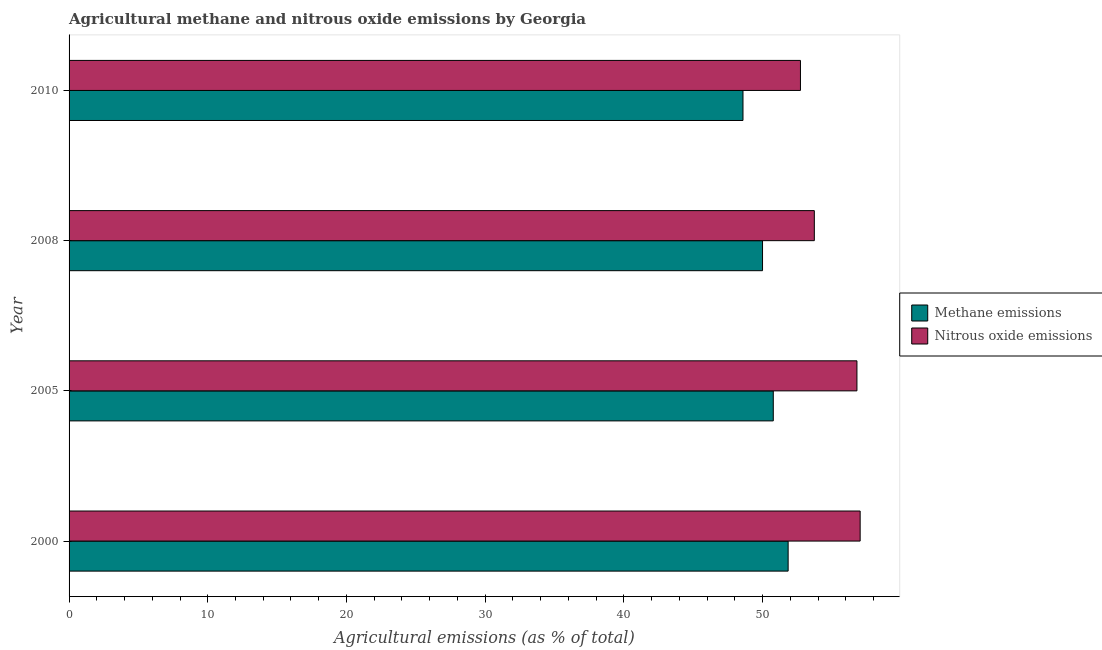How many different coloured bars are there?
Offer a terse response. 2. How many groups of bars are there?
Your answer should be very brief. 4. Are the number of bars per tick equal to the number of legend labels?
Your response must be concise. Yes. Are the number of bars on each tick of the Y-axis equal?
Make the answer very short. Yes. What is the amount of nitrous oxide emissions in 2005?
Keep it short and to the point. 56.81. Across all years, what is the maximum amount of nitrous oxide emissions?
Provide a short and direct response. 57.04. Across all years, what is the minimum amount of methane emissions?
Provide a short and direct response. 48.59. What is the total amount of nitrous oxide emissions in the graph?
Your answer should be compact. 220.31. What is the difference between the amount of nitrous oxide emissions in 2005 and that in 2008?
Keep it short and to the point. 3.07. What is the difference between the amount of methane emissions in 2005 and the amount of nitrous oxide emissions in 2010?
Provide a short and direct response. -1.96. What is the average amount of methane emissions per year?
Provide a succinct answer. 50.3. In the year 2010, what is the difference between the amount of methane emissions and amount of nitrous oxide emissions?
Provide a succinct answer. -4.14. In how many years, is the amount of nitrous oxide emissions greater than 8 %?
Your response must be concise. 4. What is the difference between the highest and the second highest amount of methane emissions?
Your answer should be compact. 1.07. Is the sum of the amount of methane emissions in 2000 and 2005 greater than the maximum amount of nitrous oxide emissions across all years?
Keep it short and to the point. Yes. What does the 2nd bar from the top in 2010 represents?
Ensure brevity in your answer.  Methane emissions. What does the 1st bar from the bottom in 2008 represents?
Offer a very short reply. Methane emissions. How many years are there in the graph?
Provide a short and direct response. 4. Are the values on the major ticks of X-axis written in scientific E-notation?
Your response must be concise. No. Does the graph contain any zero values?
Provide a succinct answer. No. How many legend labels are there?
Your answer should be compact. 2. How are the legend labels stacked?
Ensure brevity in your answer.  Vertical. What is the title of the graph?
Give a very brief answer. Agricultural methane and nitrous oxide emissions by Georgia. Does "Register a property" appear as one of the legend labels in the graph?
Ensure brevity in your answer.  No. What is the label or title of the X-axis?
Keep it short and to the point. Agricultural emissions (as % of total). What is the label or title of the Y-axis?
Your answer should be compact. Year. What is the Agricultural emissions (as % of total) of Methane emissions in 2000?
Make the answer very short. 51.84. What is the Agricultural emissions (as % of total) in Nitrous oxide emissions in 2000?
Offer a very short reply. 57.04. What is the Agricultural emissions (as % of total) in Methane emissions in 2005?
Keep it short and to the point. 50.77. What is the Agricultural emissions (as % of total) of Nitrous oxide emissions in 2005?
Offer a terse response. 56.81. What is the Agricultural emissions (as % of total) of Methane emissions in 2008?
Give a very brief answer. 50. What is the Agricultural emissions (as % of total) in Nitrous oxide emissions in 2008?
Offer a terse response. 53.73. What is the Agricultural emissions (as % of total) of Methane emissions in 2010?
Make the answer very short. 48.59. What is the Agricultural emissions (as % of total) of Nitrous oxide emissions in 2010?
Provide a succinct answer. 52.73. Across all years, what is the maximum Agricultural emissions (as % of total) of Methane emissions?
Provide a succinct answer. 51.84. Across all years, what is the maximum Agricultural emissions (as % of total) in Nitrous oxide emissions?
Provide a succinct answer. 57.04. Across all years, what is the minimum Agricultural emissions (as % of total) in Methane emissions?
Offer a terse response. 48.59. Across all years, what is the minimum Agricultural emissions (as % of total) in Nitrous oxide emissions?
Offer a terse response. 52.73. What is the total Agricultural emissions (as % of total) in Methane emissions in the graph?
Offer a very short reply. 201.2. What is the total Agricultural emissions (as % of total) in Nitrous oxide emissions in the graph?
Provide a short and direct response. 220.31. What is the difference between the Agricultural emissions (as % of total) in Methane emissions in 2000 and that in 2005?
Your answer should be very brief. 1.07. What is the difference between the Agricultural emissions (as % of total) of Nitrous oxide emissions in 2000 and that in 2005?
Offer a very short reply. 0.23. What is the difference between the Agricultural emissions (as % of total) in Methane emissions in 2000 and that in 2008?
Keep it short and to the point. 1.85. What is the difference between the Agricultural emissions (as % of total) of Nitrous oxide emissions in 2000 and that in 2008?
Provide a short and direct response. 3.3. What is the difference between the Agricultural emissions (as % of total) of Methane emissions in 2000 and that in 2010?
Your response must be concise. 3.26. What is the difference between the Agricultural emissions (as % of total) of Nitrous oxide emissions in 2000 and that in 2010?
Make the answer very short. 4.3. What is the difference between the Agricultural emissions (as % of total) in Methane emissions in 2005 and that in 2008?
Your answer should be compact. 0.77. What is the difference between the Agricultural emissions (as % of total) in Nitrous oxide emissions in 2005 and that in 2008?
Provide a succinct answer. 3.07. What is the difference between the Agricultural emissions (as % of total) in Methane emissions in 2005 and that in 2010?
Make the answer very short. 2.18. What is the difference between the Agricultural emissions (as % of total) in Nitrous oxide emissions in 2005 and that in 2010?
Give a very brief answer. 4.07. What is the difference between the Agricultural emissions (as % of total) in Methane emissions in 2008 and that in 2010?
Provide a short and direct response. 1.41. What is the difference between the Agricultural emissions (as % of total) in Nitrous oxide emissions in 2008 and that in 2010?
Offer a terse response. 1. What is the difference between the Agricultural emissions (as % of total) in Methane emissions in 2000 and the Agricultural emissions (as % of total) in Nitrous oxide emissions in 2005?
Your answer should be very brief. -4.96. What is the difference between the Agricultural emissions (as % of total) in Methane emissions in 2000 and the Agricultural emissions (as % of total) in Nitrous oxide emissions in 2008?
Your answer should be compact. -1.89. What is the difference between the Agricultural emissions (as % of total) in Methane emissions in 2000 and the Agricultural emissions (as % of total) in Nitrous oxide emissions in 2010?
Ensure brevity in your answer.  -0.89. What is the difference between the Agricultural emissions (as % of total) of Methane emissions in 2005 and the Agricultural emissions (as % of total) of Nitrous oxide emissions in 2008?
Provide a succinct answer. -2.96. What is the difference between the Agricultural emissions (as % of total) of Methane emissions in 2005 and the Agricultural emissions (as % of total) of Nitrous oxide emissions in 2010?
Make the answer very short. -1.96. What is the difference between the Agricultural emissions (as % of total) in Methane emissions in 2008 and the Agricultural emissions (as % of total) in Nitrous oxide emissions in 2010?
Keep it short and to the point. -2.73. What is the average Agricultural emissions (as % of total) of Methane emissions per year?
Ensure brevity in your answer.  50.3. What is the average Agricultural emissions (as % of total) of Nitrous oxide emissions per year?
Your answer should be compact. 55.08. In the year 2000, what is the difference between the Agricultural emissions (as % of total) of Methane emissions and Agricultural emissions (as % of total) of Nitrous oxide emissions?
Offer a terse response. -5.19. In the year 2005, what is the difference between the Agricultural emissions (as % of total) in Methane emissions and Agricultural emissions (as % of total) in Nitrous oxide emissions?
Keep it short and to the point. -6.03. In the year 2008, what is the difference between the Agricultural emissions (as % of total) in Methane emissions and Agricultural emissions (as % of total) in Nitrous oxide emissions?
Give a very brief answer. -3.73. In the year 2010, what is the difference between the Agricultural emissions (as % of total) of Methane emissions and Agricultural emissions (as % of total) of Nitrous oxide emissions?
Your answer should be very brief. -4.14. What is the ratio of the Agricultural emissions (as % of total) in Methane emissions in 2000 to that in 2005?
Keep it short and to the point. 1.02. What is the ratio of the Agricultural emissions (as % of total) in Methane emissions in 2000 to that in 2008?
Your answer should be very brief. 1.04. What is the ratio of the Agricultural emissions (as % of total) of Nitrous oxide emissions in 2000 to that in 2008?
Offer a terse response. 1.06. What is the ratio of the Agricultural emissions (as % of total) of Methane emissions in 2000 to that in 2010?
Offer a terse response. 1.07. What is the ratio of the Agricultural emissions (as % of total) in Nitrous oxide emissions in 2000 to that in 2010?
Provide a short and direct response. 1.08. What is the ratio of the Agricultural emissions (as % of total) of Methane emissions in 2005 to that in 2008?
Provide a short and direct response. 1.02. What is the ratio of the Agricultural emissions (as % of total) in Nitrous oxide emissions in 2005 to that in 2008?
Your response must be concise. 1.06. What is the ratio of the Agricultural emissions (as % of total) in Methane emissions in 2005 to that in 2010?
Your answer should be very brief. 1.04. What is the ratio of the Agricultural emissions (as % of total) of Nitrous oxide emissions in 2005 to that in 2010?
Give a very brief answer. 1.08. What is the ratio of the Agricultural emissions (as % of total) of Methane emissions in 2008 to that in 2010?
Your answer should be compact. 1.03. What is the ratio of the Agricultural emissions (as % of total) in Nitrous oxide emissions in 2008 to that in 2010?
Your answer should be very brief. 1.02. What is the difference between the highest and the second highest Agricultural emissions (as % of total) in Methane emissions?
Offer a terse response. 1.07. What is the difference between the highest and the second highest Agricultural emissions (as % of total) of Nitrous oxide emissions?
Offer a terse response. 0.23. What is the difference between the highest and the lowest Agricultural emissions (as % of total) of Methane emissions?
Give a very brief answer. 3.26. What is the difference between the highest and the lowest Agricultural emissions (as % of total) of Nitrous oxide emissions?
Make the answer very short. 4.3. 